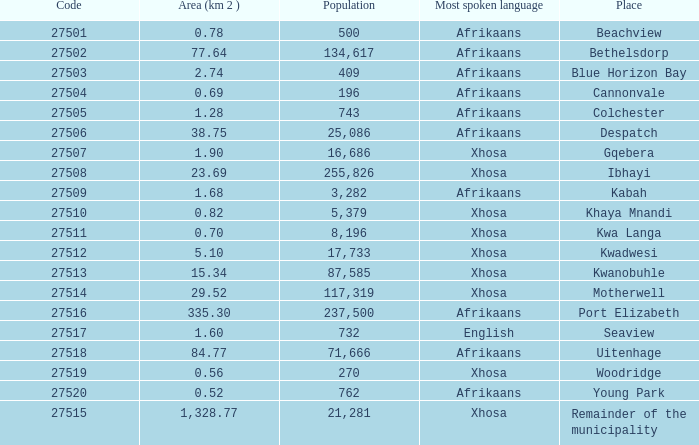What is the total code number for places with a population greater than 87,585? 4.0. 